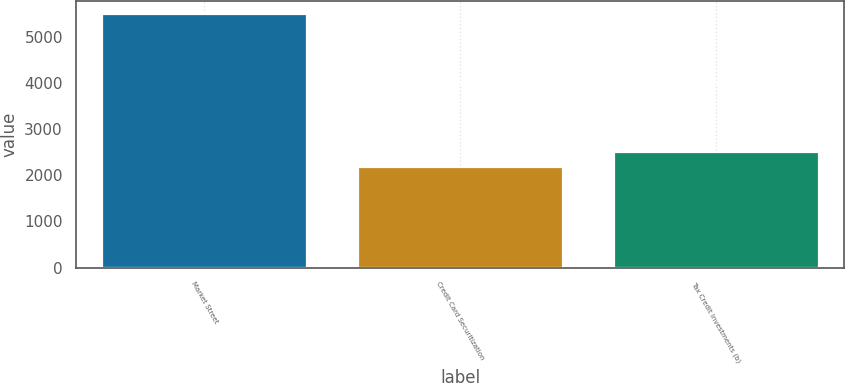Convert chart. <chart><loc_0><loc_0><loc_500><loc_500><bar_chart><fcel>Market Street<fcel>Credit Card Securitization<fcel>Tax Credit Investments (b)<nl><fcel>5490<fcel>2175<fcel>2506.5<nl></chart> 